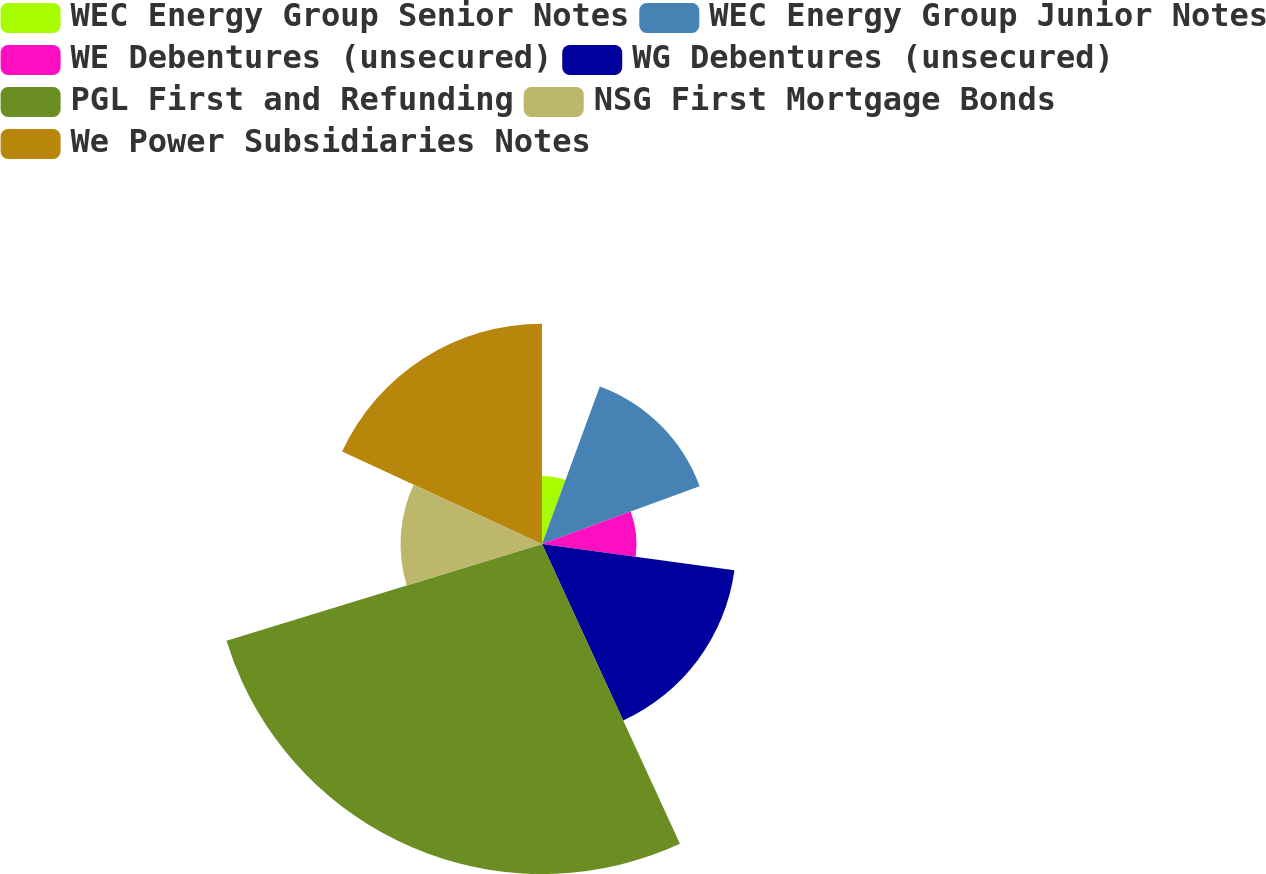Convert chart to OTSL. <chart><loc_0><loc_0><loc_500><loc_500><pie_chart><fcel>WEC Energy Group Senior Notes<fcel>WEC Energy Group Junior Notes<fcel>WE Debentures (unsecured)<fcel>WG Debentures (unsecured)<fcel>PGL First and Refunding<fcel>NSG First Mortgage Bonds<fcel>We Power Subsidiaries Notes<nl><fcel>5.6%<fcel>13.8%<fcel>7.77%<fcel>15.97%<fcel>27.13%<fcel>11.63%<fcel>18.11%<nl></chart> 